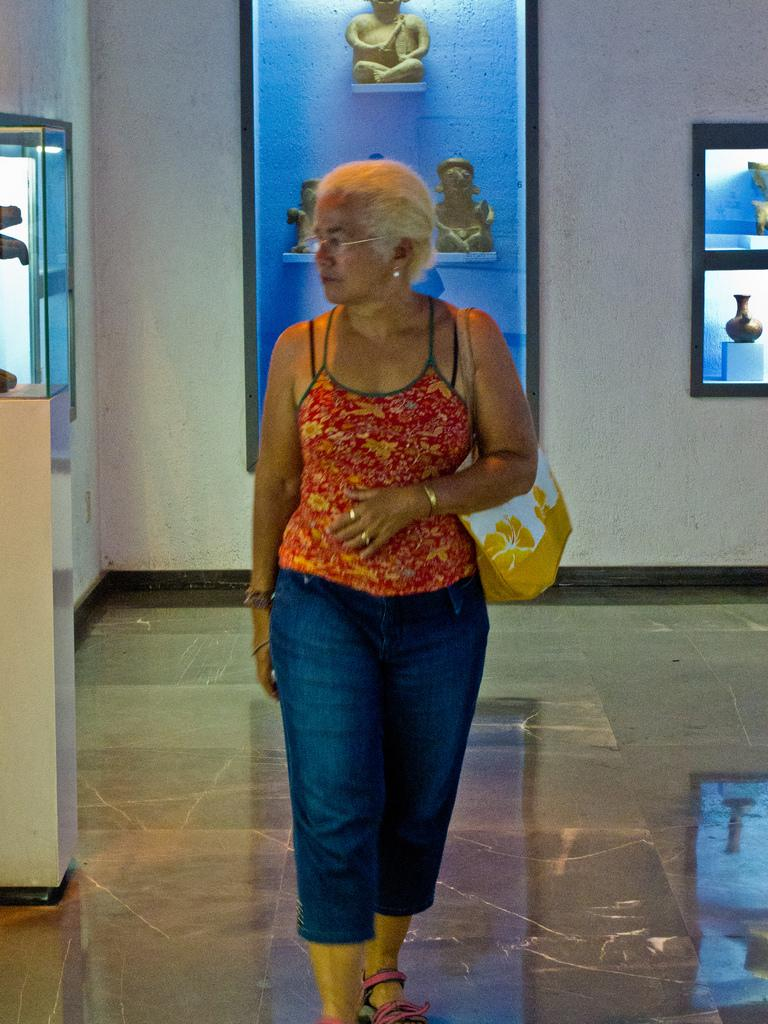What type of structure can be seen in the image? There is a wall in the image. What decorative items are present on the wall? There are photo frames in the image. Are there any sculptures visible in the image? Yes, there are statues in the image. What is the woman in the image holding? The woman is holding a handbag in the image. What type of underwear is the woman wearing in the image? There is no information about the woman's underwear in the image, as it is not visible or mentioned in the provided facts. 